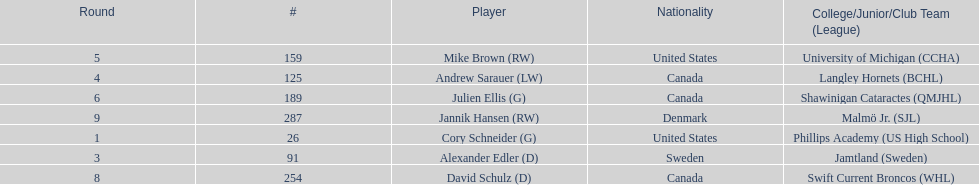What number of players have canada listed as their nationality? 3. 